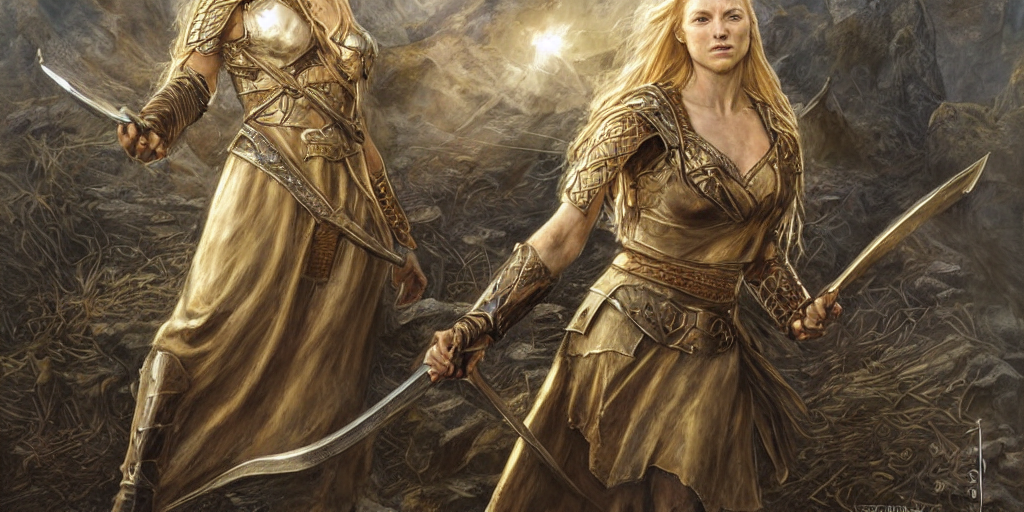Can you describe the attire of the characters in this image? Certainly! The characters are clad in elaborate medieval or fantasy-inspired armor that includes decorated breastplates, shoulder guards, and bracers. Their attire is complemented by flowing dresses, which suggest a combination of elegance and battle-readiness. 